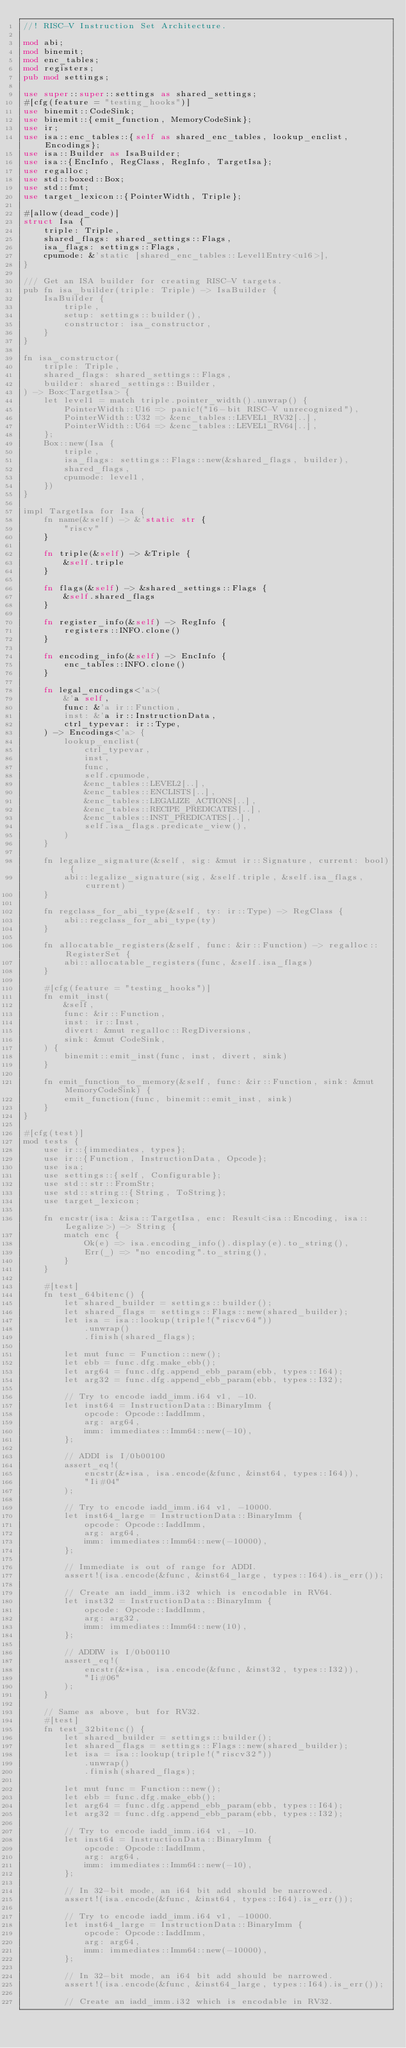<code> <loc_0><loc_0><loc_500><loc_500><_Rust_>//! RISC-V Instruction Set Architecture.

mod abi;
mod binemit;
mod enc_tables;
mod registers;
pub mod settings;

use super::super::settings as shared_settings;
#[cfg(feature = "testing_hooks")]
use binemit::CodeSink;
use binemit::{emit_function, MemoryCodeSink};
use ir;
use isa::enc_tables::{self as shared_enc_tables, lookup_enclist, Encodings};
use isa::Builder as IsaBuilder;
use isa::{EncInfo, RegClass, RegInfo, TargetIsa};
use regalloc;
use std::boxed::Box;
use std::fmt;
use target_lexicon::{PointerWidth, Triple};

#[allow(dead_code)]
struct Isa {
    triple: Triple,
    shared_flags: shared_settings::Flags,
    isa_flags: settings::Flags,
    cpumode: &'static [shared_enc_tables::Level1Entry<u16>],
}

/// Get an ISA builder for creating RISC-V targets.
pub fn isa_builder(triple: Triple) -> IsaBuilder {
    IsaBuilder {
        triple,
        setup: settings::builder(),
        constructor: isa_constructor,
    }
}

fn isa_constructor(
    triple: Triple,
    shared_flags: shared_settings::Flags,
    builder: shared_settings::Builder,
) -> Box<TargetIsa> {
    let level1 = match triple.pointer_width().unwrap() {
        PointerWidth::U16 => panic!("16-bit RISC-V unrecognized"),
        PointerWidth::U32 => &enc_tables::LEVEL1_RV32[..],
        PointerWidth::U64 => &enc_tables::LEVEL1_RV64[..],
    };
    Box::new(Isa {
        triple,
        isa_flags: settings::Flags::new(&shared_flags, builder),
        shared_flags,
        cpumode: level1,
    })
}

impl TargetIsa for Isa {
    fn name(&self) -> &'static str {
        "riscv"
    }

    fn triple(&self) -> &Triple {
        &self.triple
    }

    fn flags(&self) -> &shared_settings::Flags {
        &self.shared_flags
    }

    fn register_info(&self) -> RegInfo {
        registers::INFO.clone()
    }

    fn encoding_info(&self) -> EncInfo {
        enc_tables::INFO.clone()
    }

    fn legal_encodings<'a>(
        &'a self,
        func: &'a ir::Function,
        inst: &'a ir::InstructionData,
        ctrl_typevar: ir::Type,
    ) -> Encodings<'a> {
        lookup_enclist(
            ctrl_typevar,
            inst,
            func,
            self.cpumode,
            &enc_tables::LEVEL2[..],
            &enc_tables::ENCLISTS[..],
            &enc_tables::LEGALIZE_ACTIONS[..],
            &enc_tables::RECIPE_PREDICATES[..],
            &enc_tables::INST_PREDICATES[..],
            self.isa_flags.predicate_view(),
        )
    }

    fn legalize_signature(&self, sig: &mut ir::Signature, current: bool) {
        abi::legalize_signature(sig, &self.triple, &self.isa_flags, current)
    }

    fn regclass_for_abi_type(&self, ty: ir::Type) -> RegClass {
        abi::regclass_for_abi_type(ty)
    }

    fn allocatable_registers(&self, func: &ir::Function) -> regalloc::RegisterSet {
        abi::allocatable_registers(func, &self.isa_flags)
    }

    #[cfg(feature = "testing_hooks")]
    fn emit_inst(
        &self,
        func: &ir::Function,
        inst: ir::Inst,
        divert: &mut regalloc::RegDiversions,
        sink: &mut CodeSink,
    ) {
        binemit::emit_inst(func, inst, divert, sink)
    }

    fn emit_function_to_memory(&self, func: &ir::Function, sink: &mut MemoryCodeSink) {
        emit_function(func, binemit::emit_inst, sink)
    }
}

#[cfg(test)]
mod tests {
    use ir::{immediates, types};
    use ir::{Function, InstructionData, Opcode};
    use isa;
    use settings::{self, Configurable};
    use std::str::FromStr;
    use std::string::{String, ToString};
    use target_lexicon;

    fn encstr(isa: &isa::TargetIsa, enc: Result<isa::Encoding, isa::Legalize>) -> String {
        match enc {
            Ok(e) => isa.encoding_info().display(e).to_string(),
            Err(_) => "no encoding".to_string(),
        }
    }

    #[test]
    fn test_64bitenc() {
        let shared_builder = settings::builder();
        let shared_flags = settings::Flags::new(shared_builder);
        let isa = isa::lookup(triple!("riscv64"))
            .unwrap()
            .finish(shared_flags);

        let mut func = Function::new();
        let ebb = func.dfg.make_ebb();
        let arg64 = func.dfg.append_ebb_param(ebb, types::I64);
        let arg32 = func.dfg.append_ebb_param(ebb, types::I32);

        // Try to encode iadd_imm.i64 v1, -10.
        let inst64 = InstructionData::BinaryImm {
            opcode: Opcode::IaddImm,
            arg: arg64,
            imm: immediates::Imm64::new(-10),
        };

        // ADDI is I/0b00100
        assert_eq!(
            encstr(&*isa, isa.encode(&func, &inst64, types::I64)),
            "Ii#04"
        );

        // Try to encode iadd_imm.i64 v1, -10000.
        let inst64_large = InstructionData::BinaryImm {
            opcode: Opcode::IaddImm,
            arg: arg64,
            imm: immediates::Imm64::new(-10000),
        };

        // Immediate is out of range for ADDI.
        assert!(isa.encode(&func, &inst64_large, types::I64).is_err());

        // Create an iadd_imm.i32 which is encodable in RV64.
        let inst32 = InstructionData::BinaryImm {
            opcode: Opcode::IaddImm,
            arg: arg32,
            imm: immediates::Imm64::new(10),
        };

        // ADDIW is I/0b00110
        assert_eq!(
            encstr(&*isa, isa.encode(&func, &inst32, types::I32)),
            "Ii#06"
        );
    }

    // Same as above, but for RV32.
    #[test]
    fn test_32bitenc() {
        let shared_builder = settings::builder();
        let shared_flags = settings::Flags::new(shared_builder);
        let isa = isa::lookup(triple!("riscv32"))
            .unwrap()
            .finish(shared_flags);

        let mut func = Function::new();
        let ebb = func.dfg.make_ebb();
        let arg64 = func.dfg.append_ebb_param(ebb, types::I64);
        let arg32 = func.dfg.append_ebb_param(ebb, types::I32);

        // Try to encode iadd_imm.i64 v1, -10.
        let inst64 = InstructionData::BinaryImm {
            opcode: Opcode::IaddImm,
            arg: arg64,
            imm: immediates::Imm64::new(-10),
        };

        // In 32-bit mode, an i64 bit add should be narrowed.
        assert!(isa.encode(&func, &inst64, types::I64).is_err());

        // Try to encode iadd_imm.i64 v1, -10000.
        let inst64_large = InstructionData::BinaryImm {
            opcode: Opcode::IaddImm,
            arg: arg64,
            imm: immediates::Imm64::new(-10000),
        };

        // In 32-bit mode, an i64 bit add should be narrowed.
        assert!(isa.encode(&func, &inst64_large, types::I64).is_err());

        // Create an iadd_imm.i32 which is encodable in RV32.</code> 